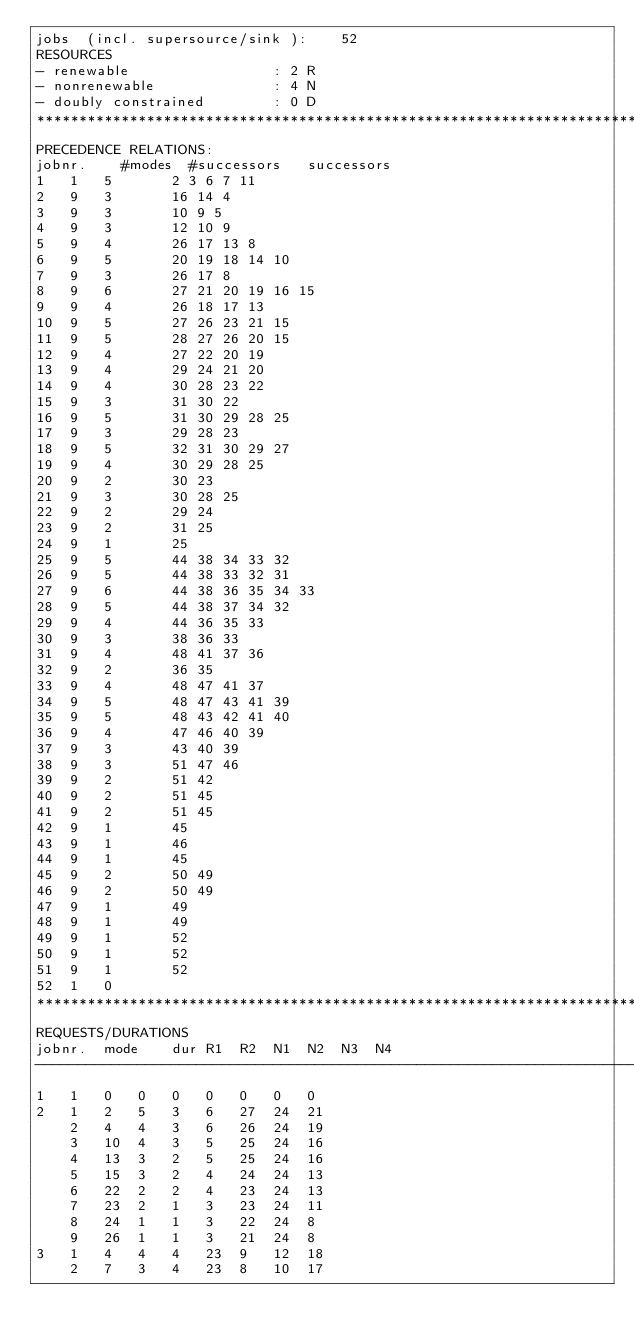<code> <loc_0><loc_0><loc_500><loc_500><_ObjectiveC_>jobs  (incl. supersource/sink ):	52
RESOURCES
- renewable                 : 2 R
- nonrenewable              : 4 N
- doubly constrained        : 0 D
************************************************************************
PRECEDENCE RELATIONS:
jobnr.    #modes  #successors   successors
1	1	5		2 3 6 7 11 
2	9	3		16 14 4 
3	9	3		10 9 5 
4	9	3		12 10 9 
5	9	4		26 17 13 8 
6	9	5		20 19 18 14 10 
7	9	3		26 17 8 
8	9	6		27 21 20 19 16 15 
9	9	4		26 18 17 13 
10	9	5		27 26 23 21 15 
11	9	5		28 27 26 20 15 
12	9	4		27 22 20 19 
13	9	4		29 24 21 20 
14	9	4		30 28 23 22 
15	9	3		31 30 22 
16	9	5		31 30 29 28 25 
17	9	3		29 28 23 
18	9	5		32 31 30 29 27 
19	9	4		30 29 28 25 
20	9	2		30 23 
21	9	3		30 28 25 
22	9	2		29 24 
23	9	2		31 25 
24	9	1		25 
25	9	5		44 38 34 33 32 
26	9	5		44 38 33 32 31 
27	9	6		44 38 36 35 34 33 
28	9	5		44 38 37 34 32 
29	9	4		44 36 35 33 
30	9	3		38 36 33 
31	9	4		48 41 37 36 
32	9	2		36 35 
33	9	4		48 47 41 37 
34	9	5		48 47 43 41 39 
35	9	5		48 43 42 41 40 
36	9	4		47 46 40 39 
37	9	3		43 40 39 
38	9	3		51 47 46 
39	9	2		51 42 
40	9	2		51 45 
41	9	2		51 45 
42	9	1		45 
43	9	1		46 
44	9	1		45 
45	9	2		50 49 
46	9	2		50 49 
47	9	1		49 
48	9	1		49 
49	9	1		52 
50	9	1		52 
51	9	1		52 
52	1	0		
************************************************************************
REQUESTS/DURATIONS
jobnr.	mode	dur	R1	R2	N1	N2	N3	N4	
------------------------------------------------------------------------
1	1	0	0	0	0	0	0	0	
2	1	2	5	3	6	27	24	21	
	2	4	4	3	6	26	24	19	
	3	10	4	3	5	25	24	16	
	4	13	3	2	5	25	24	16	
	5	15	3	2	4	24	24	13	
	6	22	2	2	4	23	24	13	
	7	23	2	1	3	23	24	11	
	8	24	1	1	3	22	24	8	
	9	26	1	1	3	21	24	8	
3	1	4	4	4	23	9	12	18	
	2	7	3	4	23	8	10	17	</code> 